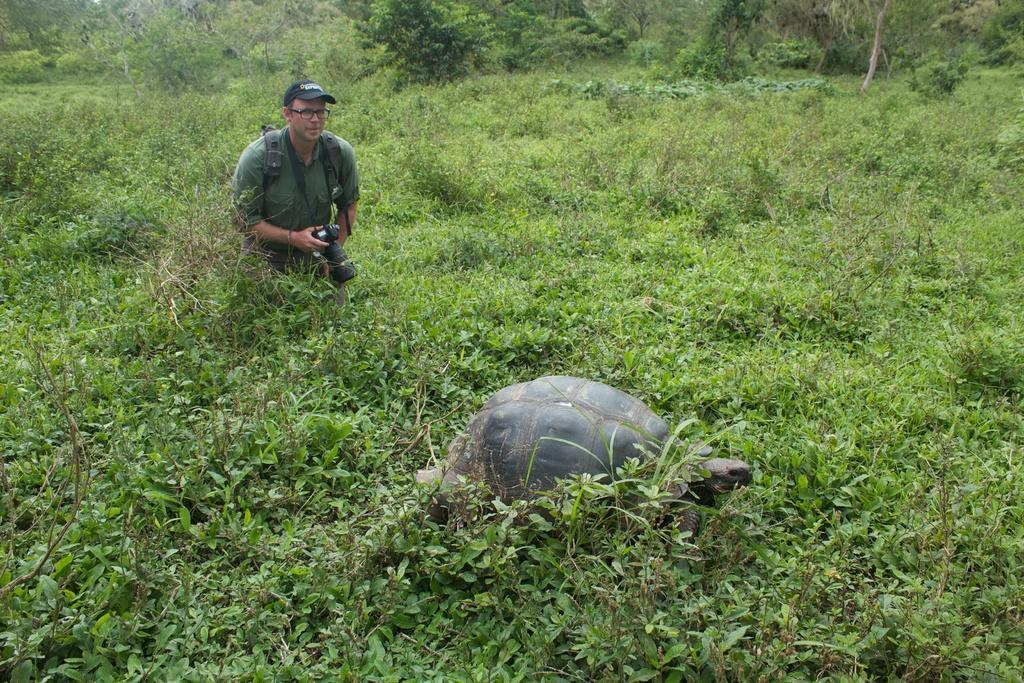Could you give a brief overview of what you see in this image? In this picture we can see a tortoise. There is a person holding a camera and standing. There are few plants and trees in the background. 